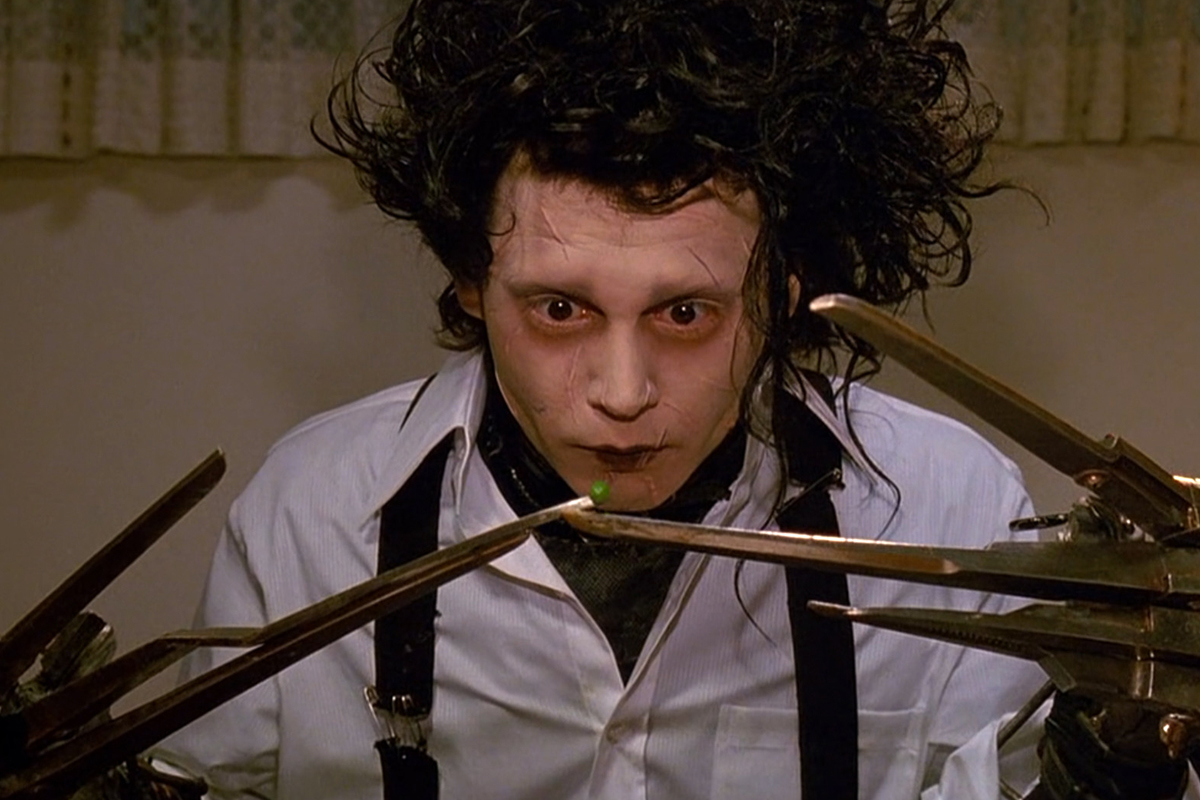What are the key elements in this picture? This image captures a memorable scene from the film "Edward Scissorhands,'' highlighting the unique character portrayed by Johnny Depp. The distinct elements include Depp's character, Edward, with his ghostly pale face, dark and intense eyes, and wild, unkempt hair. His hands, composed of sharp scissors, are prominently displayed, emphasizing the character's namesake and his unusual predicament. Edward's attire, a white shirt with black suspenders, contrasts starkly with his pale skin, further defining his eccentric appearance. The expression on his face, marked by a mix of curiosity and sadness, adds emotional depth to the scene, making it both poignant and captivating. 